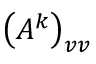<formula> <loc_0><loc_0><loc_500><loc_500>\left ( A ^ { k } \right ) _ { v v }</formula> 